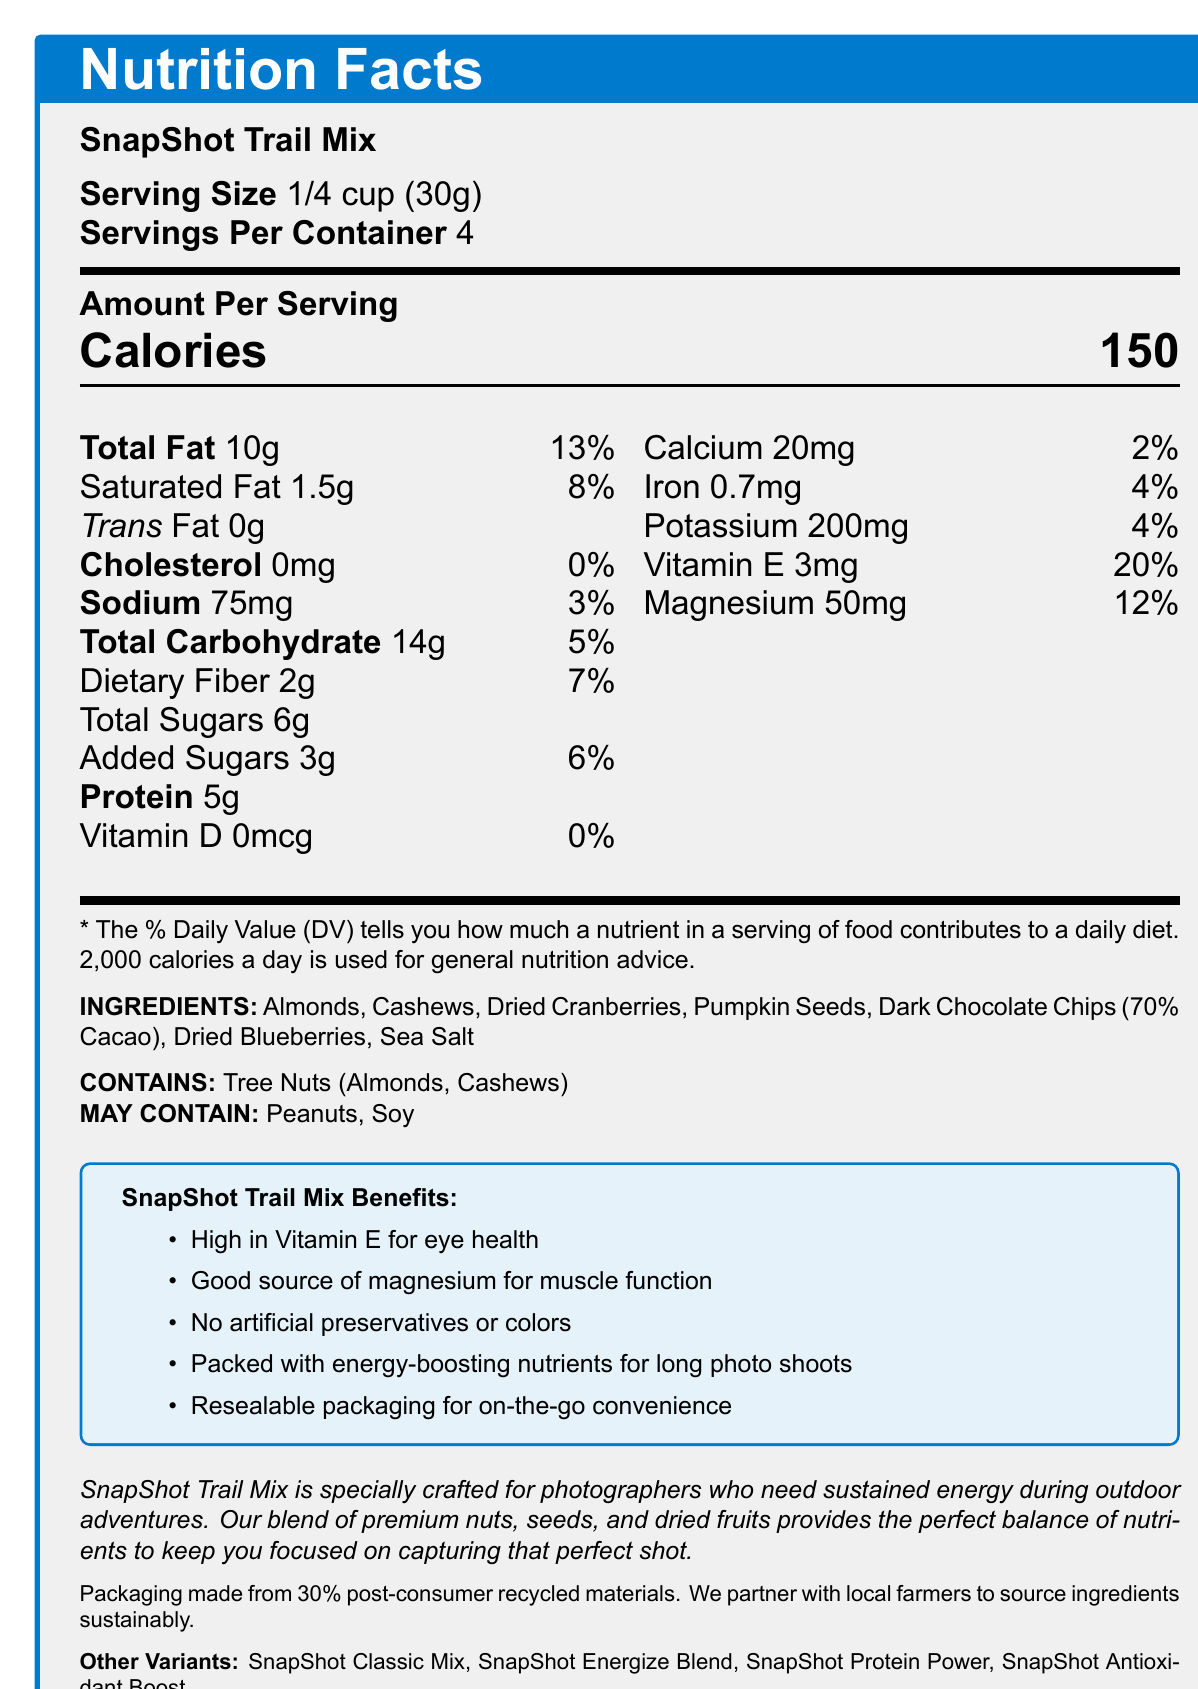what is the serving size of the SnapShot Trail Mix? The serving size information is explicitly stated in the document next to the product name.
Answer: 1/4 cup (30g) how many calories are in one serving? The number of calories per serving is located under the "Amount Per Serving" section.
Answer: 150 calories how much protein is in each serving? This information is found in the nutritional breakdown under "Protein."
Answer: 5g what are the main ingredients in this trail mix? The list of ingredients is provided at the bottom of the document.
Answer: Almonds, Cashews, Dried Cranberries, Pumpkin Seeds, Dark Chocolate Chips (70% Cacao), Dried Blueberries, Sea Salt which nutrient has the highest daily value percentage per serving? Vitamin E shows the highest daily value percentage among the nutrients listed.
Answer: Vitamin E (20%) what benefits does this trail mix offer? These benefits are listed in a tcolorbox under "SnapShot Trail Mix Benefits."
Answer: High in Vitamin E for eye health, Good source of magnesium for muscle function, No artificial preservatives or colors, Packed with energy-boosting nutrients for long photo shoots, Resealable packaging for on-the-go convenience how many servings are in one container? The number of servings per container is provided under the serving size.
Answer: 4 what percentage of daily value of magnesium does each serving of the trail mix provide? This information is found in the nutritional breakdown under "Magnesium."
Answer: 12% how many grams of added sugars are in one serving? The grams of added sugars per serving are listed in the nutritional breakdown under "Total Sugars" with a specific mention of "Added Sugars."
Answer: 3g which of the following ingredients is not found in the SnapShot Trail Mix? A. Almonds B. Walnuts C. Cashews Walnuts are not listed as an ingredient in the SnapShot Trail Mix.
Answer: B. Walnuts what are the potential allergens in the SnapShot Trail Mix? A. Tree Nuts B. Soy C. Peanuts D. All of the above This information is found under the allergens section, which lists Tree Nuts as contained and mentions potential presence of Peanuts and Soy.
Answer: D. All of the above does this product contain any artificial preservatives or colors? The document states "No artificial preservatives or colors" under the benefits section.
Answer: No describe the main idea of the SnapShot Trail Mix Nutrition Facts document. The detailed description in the document includes nutritional values, health benefits, ingredients, and the brand's story focused on providing energy-boosting and healthy snacks for photographers.
Answer: The document provides detailed nutritional information about the SnapShot Trail Mix, including serving size, calorie count, and the breakdown of various nutrients. It also lists ingredients, potential allergens, and marketing claims emphasizing health benefits and convenience for outdoor photography enthusiasts. Additionally, it highlights the brand's commitment to sustainability and offers information about product variants. who are the ingredients in the trail mix sourced from? The document only mentions that the ingredients are sourced sustainably, without specifying the suppliers.
Answer: Not enough information what is the daily value percentage of calcium in one serving? This information is part of the nutritional breakdown under "Calcium."
Answer: 2% 